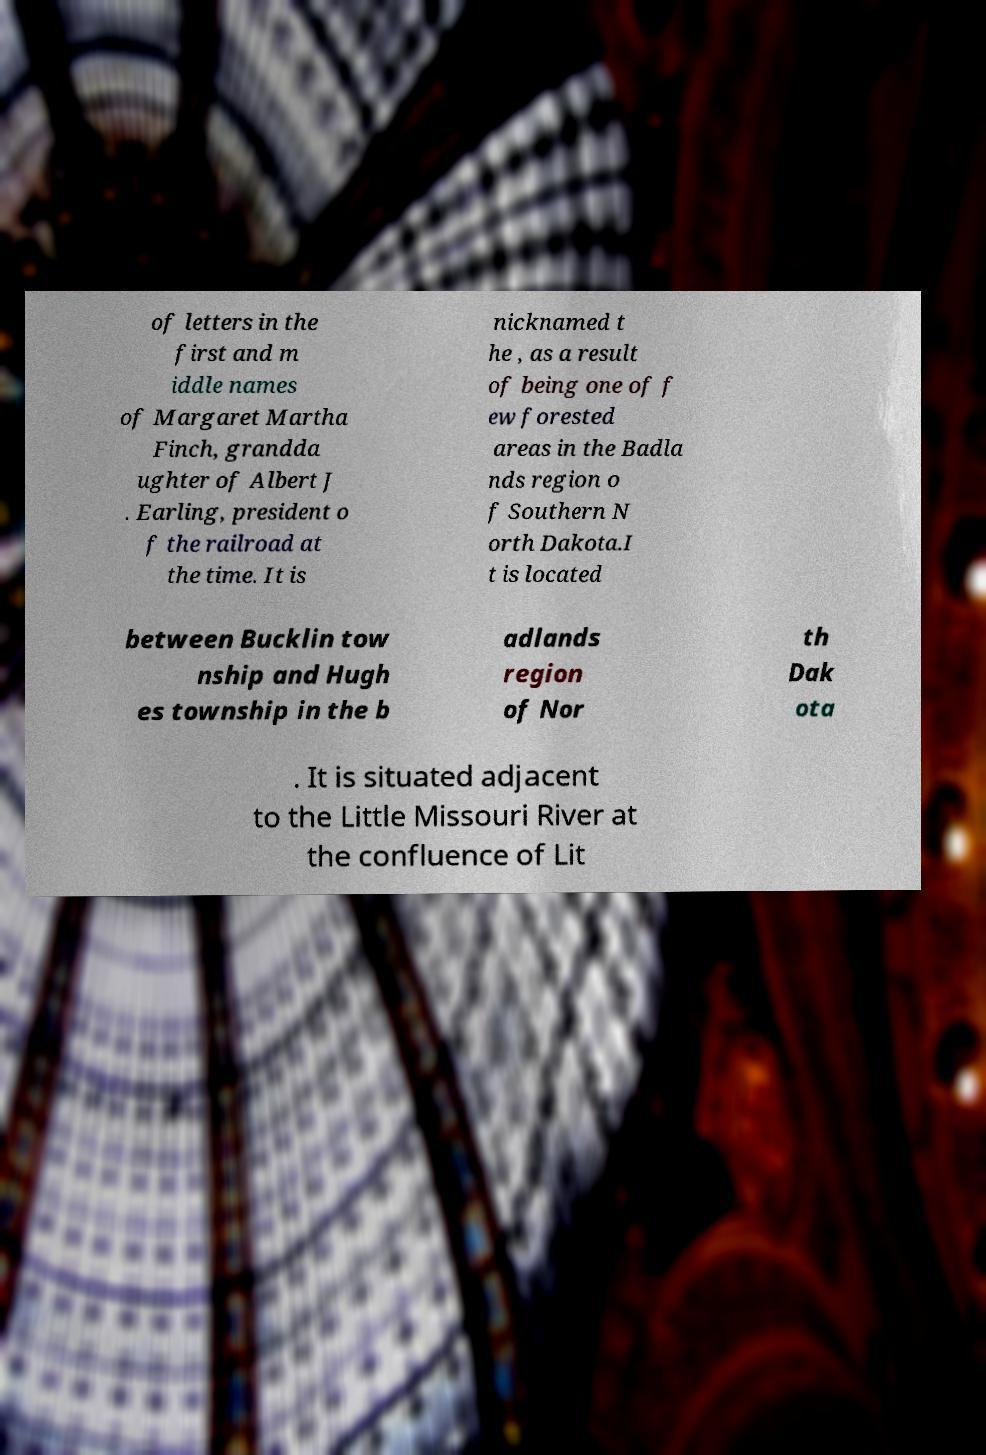Please identify and transcribe the text found in this image. of letters in the first and m iddle names of Margaret Martha Finch, grandda ughter of Albert J . Earling, president o f the railroad at the time. It is nicknamed t he , as a result of being one of f ew forested areas in the Badla nds region o f Southern N orth Dakota.I t is located between Bucklin tow nship and Hugh es township in the b adlands region of Nor th Dak ota . It is situated adjacent to the Little Missouri River at the confluence of Lit 